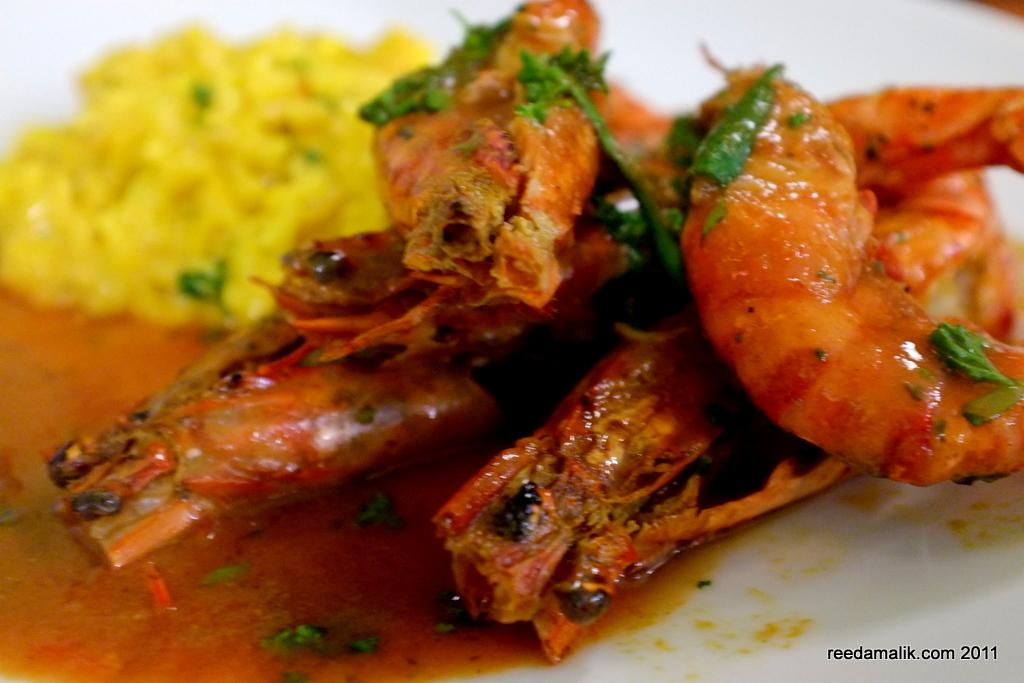What is the main object in the center of the image? There is a plate in the center of the image. What is on the plate? There are food items on the plate. Is there any text visible in the image? Yes, there is some text at the bottom right side of the image. What type of vacation is being advertised in the image? There is no vacation being advertised in the image; it only contains a plate with food items and some text. 